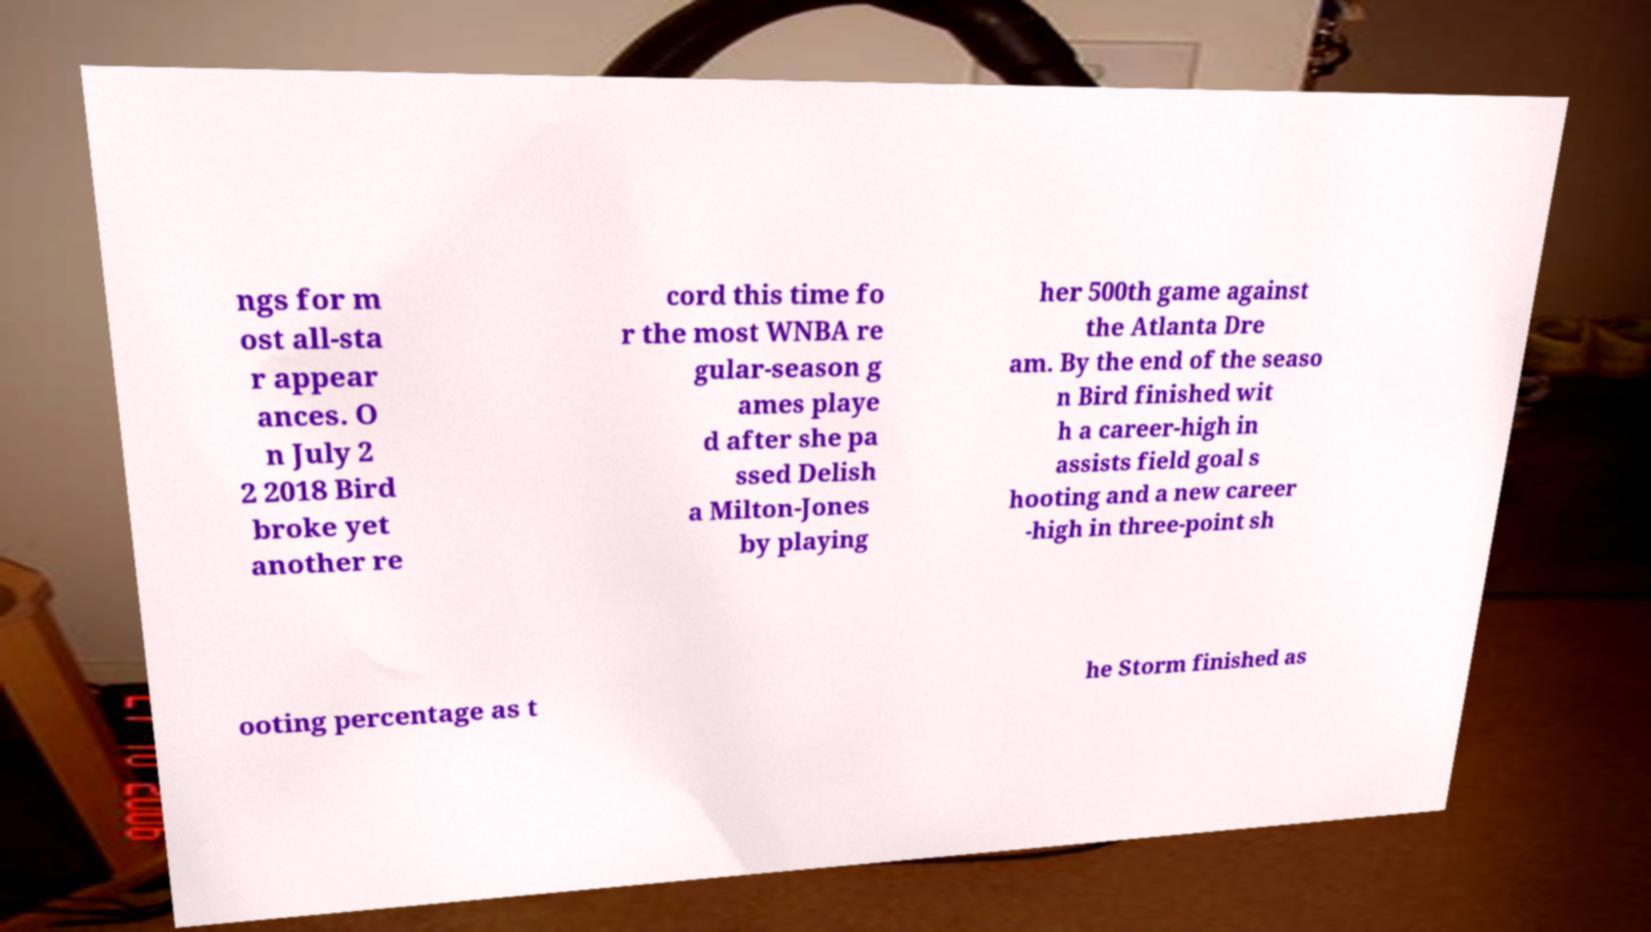Please identify and transcribe the text found in this image. ngs for m ost all-sta r appear ances. O n July 2 2 2018 Bird broke yet another re cord this time fo r the most WNBA re gular-season g ames playe d after she pa ssed Delish a Milton-Jones by playing her 500th game against the Atlanta Dre am. By the end of the seaso n Bird finished wit h a career-high in assists field goal s hooting and a new career -high in three-point sh ooting percentage as t he Storm finished as 